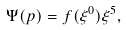<formula> <loc_0><loc_0><loc_500><loc_500>\Psi ( p ) = f ( \xi ^ { 0 } ) \xi ^ { 5 } ,</formula> 